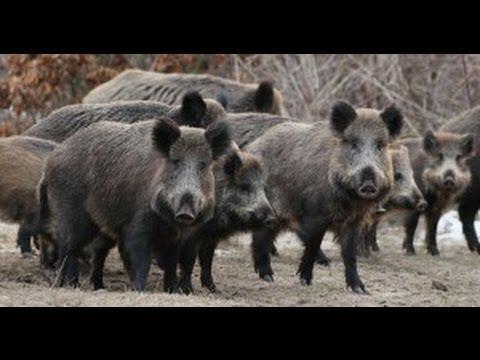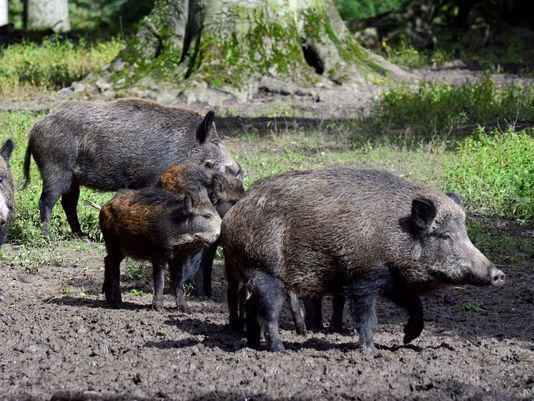The first image is the image on the left, the second image is the image on the right. Assess this claim about the two images: "Trees with green branches are behind a group of hogs in one image.". Correct or not? Answer yes or no. No. 